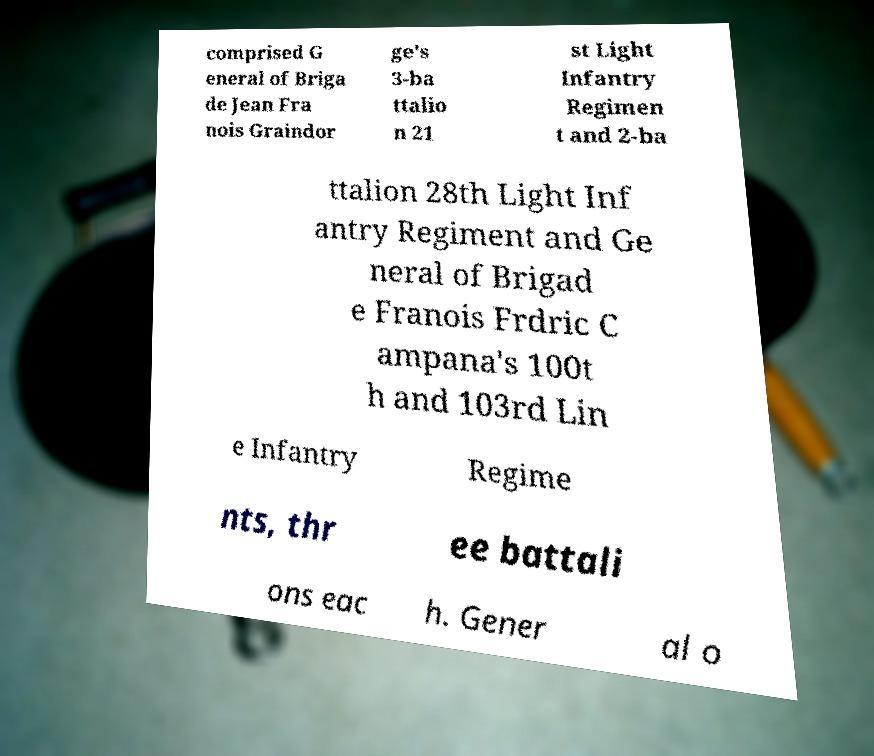Can you accurately transcribe the text from the provided image for me? comprised G eneral of Briga de Jean Fra nois Graindor ge's 3-ba ttalio n 21 st Light Infantry Regimen t and 2-ba ttalion 28th Light Inf antry Regiment and Ge neral of Brigad e Franois Frdric C ampana's 100t h and 103rd Lin e Infantry Regime nts, thr ee battali ons eac h. Gener al o 